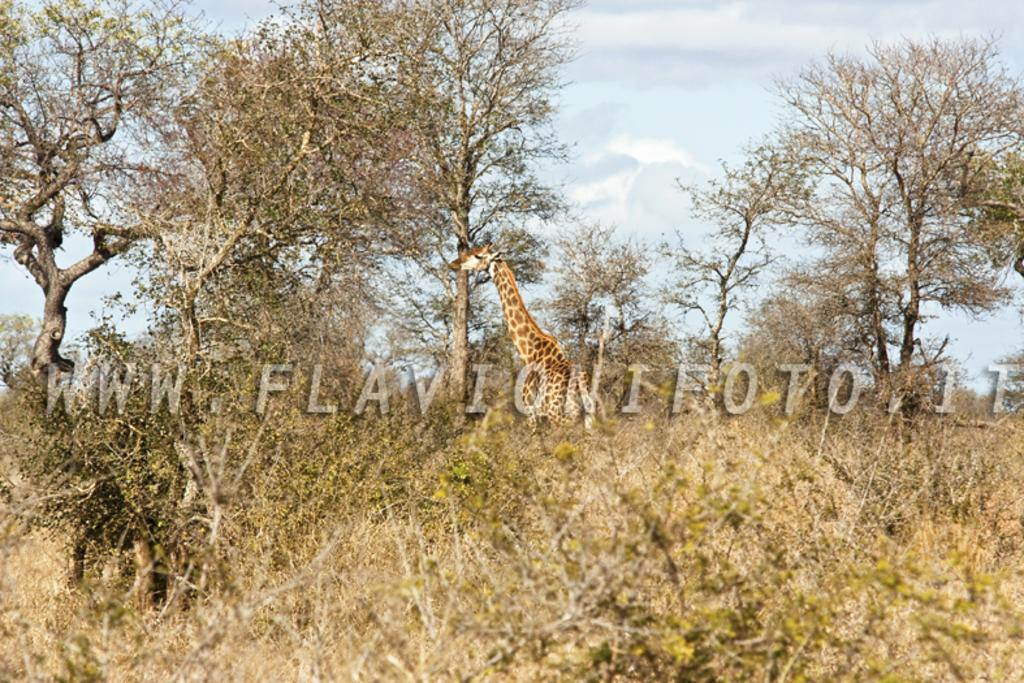What animal is located in the middle of the image? There is a giraffe in the middle of the image. What type of vegetation can be seen on the left side of the image? There are trees on the left side of the image. What type of vegetation can be seen on the right side of the image? There are trees on the right side of the image. What is visible in the background of the image? The sky is visible in the image. What can be observed in the sky? There are clouds in the sky. What type of circle is being used for learning in the image? There is no circle or learning activity present in the image. 